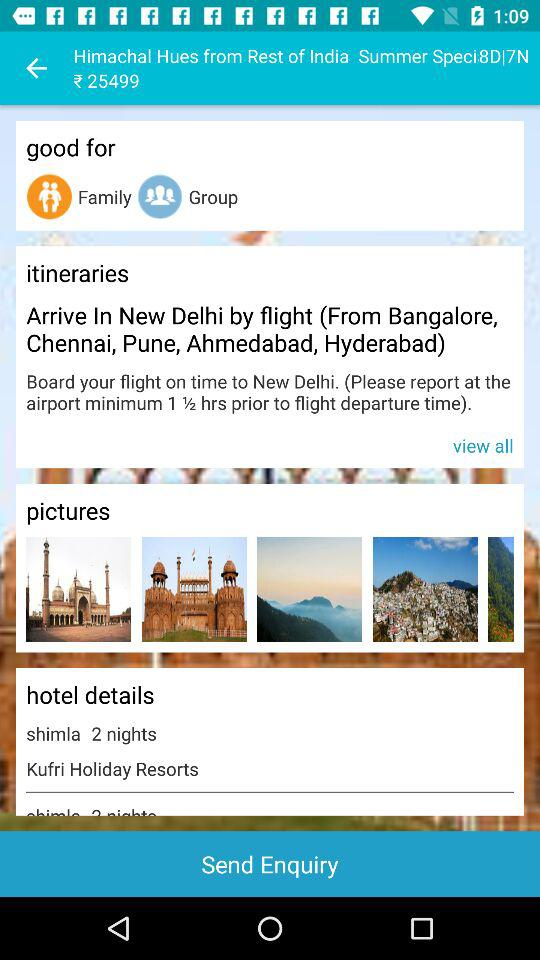What is the cost of the package for 8 days and 7 nights? The cost of the package is ₹25499. 